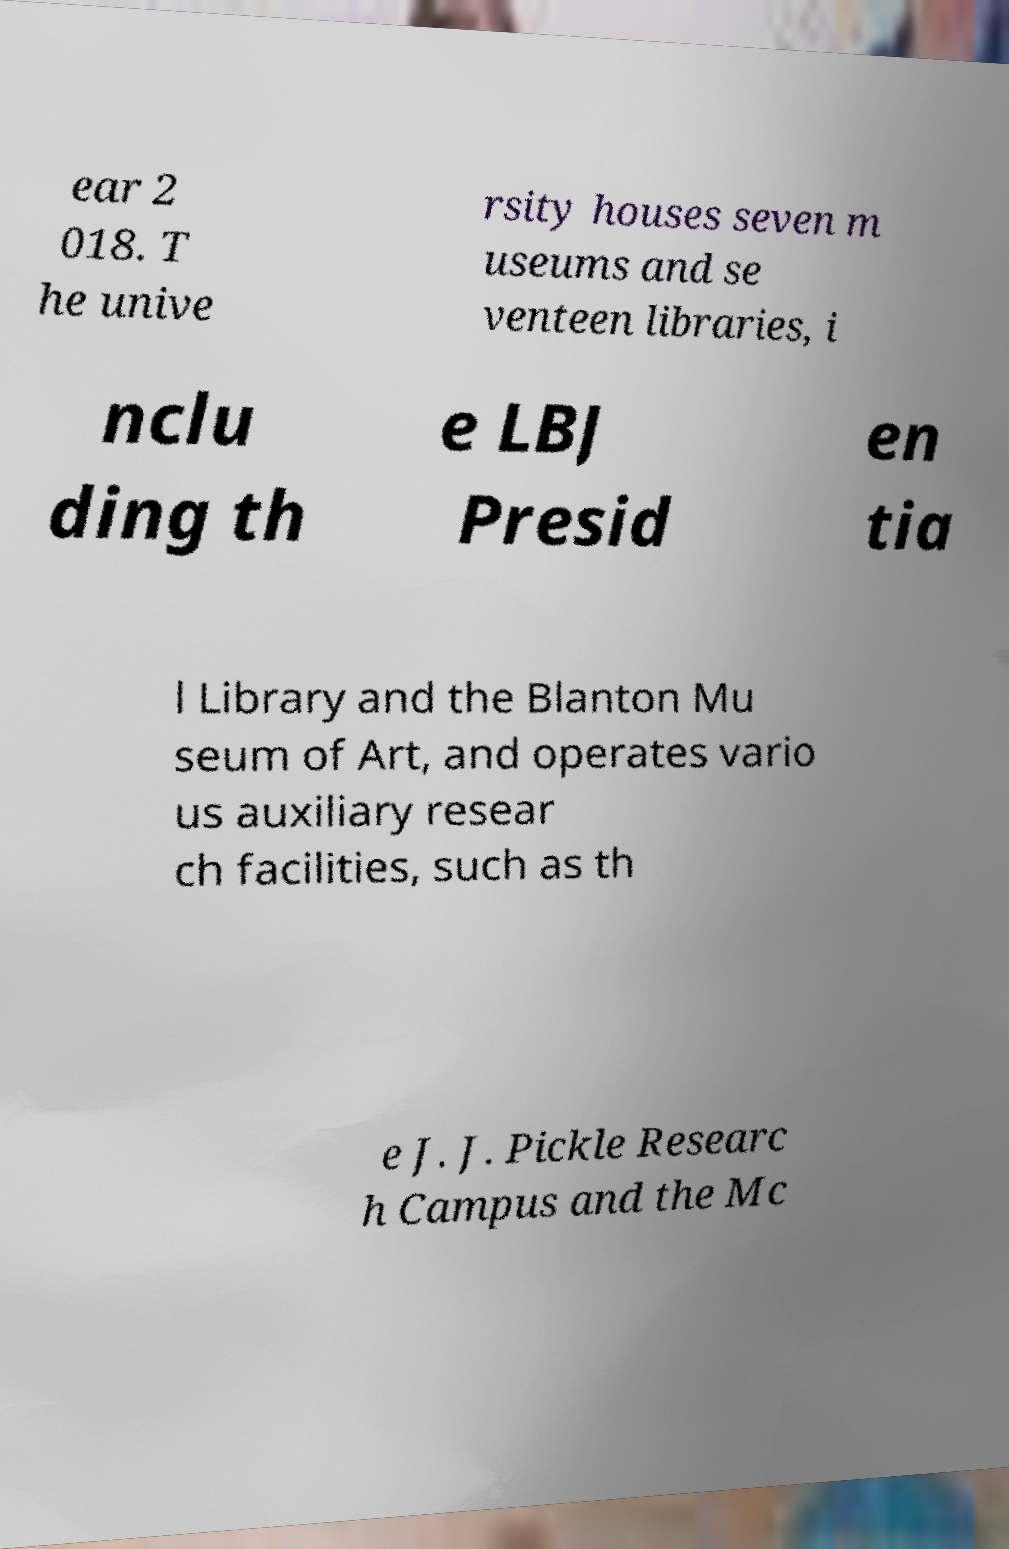There's text embedded in this image that I need extracted. Can you transcribe it verbatim? ear 2 018. T he unive rsity houses seven m useums and se venteen libraries, i nclu ding th e LBJ Presid en tia l Library and the Blanton Mu seum of Art, and operates vario us auxiliary resear ch facilities, such as th e J. J. Pickle Researc h Campus and the Mc 